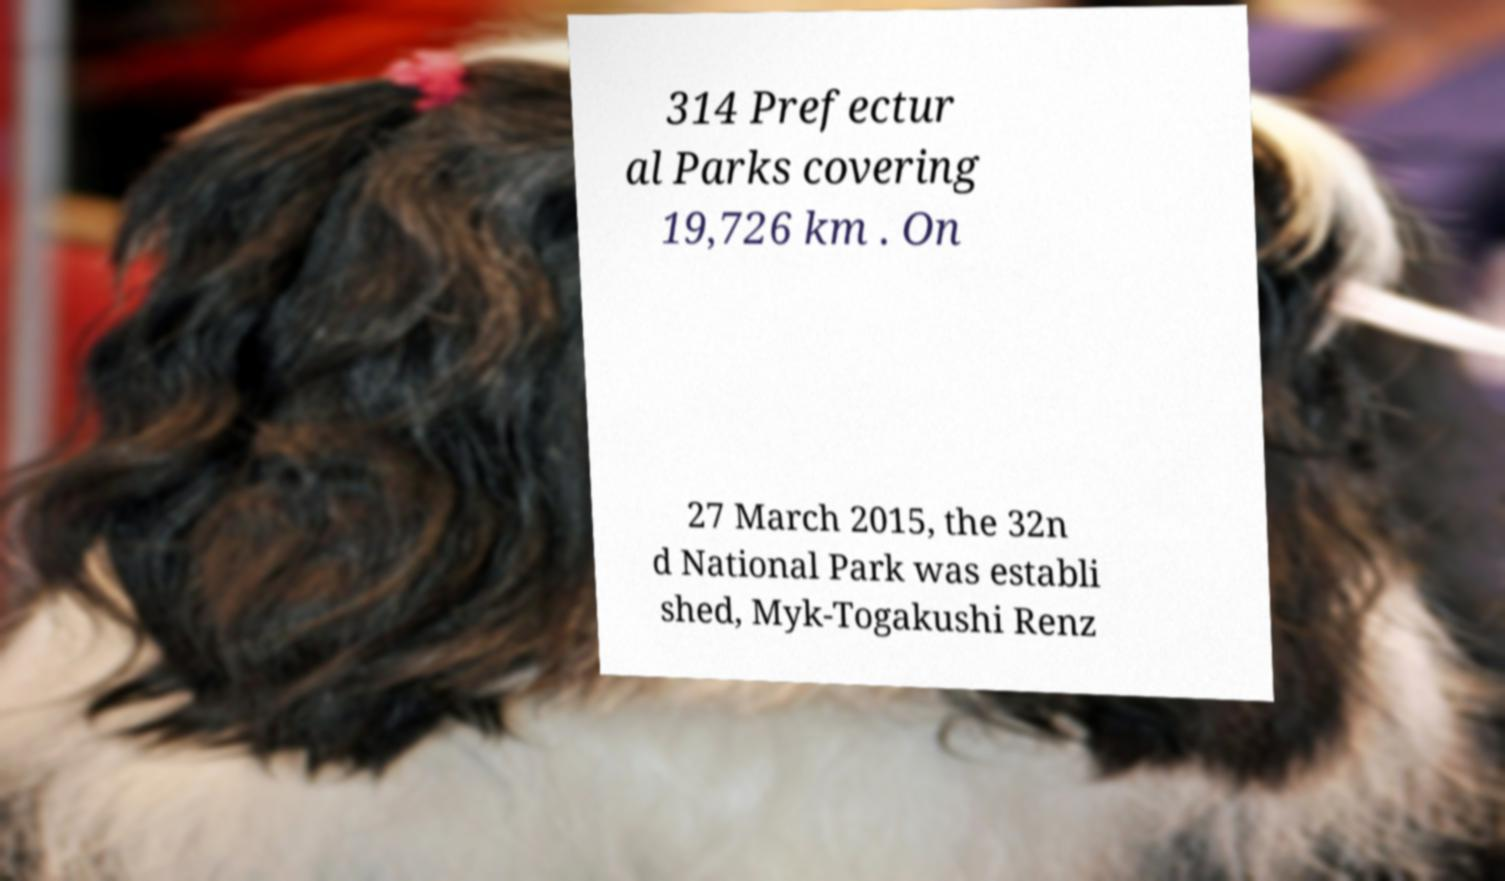Could you assist in decoding the text presented in this image and type it out clearly? 314 Prefectur al Parks covering 19,726 km . On 27 March 2015, the 32n d National Park was establi shed, Myk-Togakushi Renz 